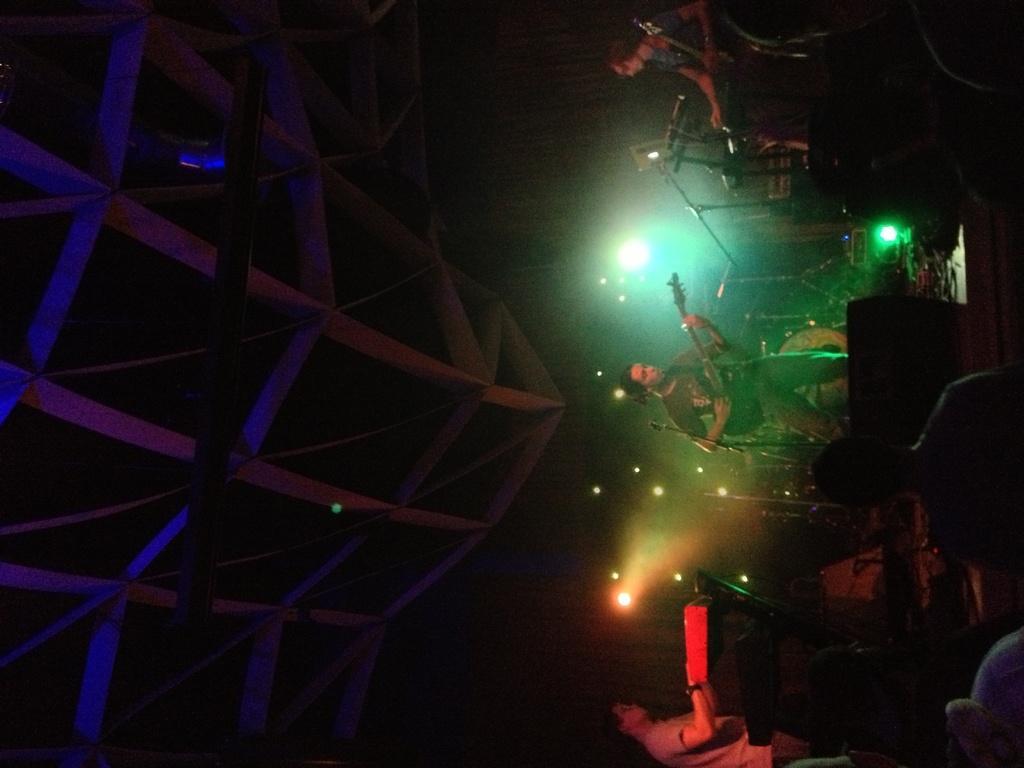In one or two sentences, can you explain what this image depicts? This is the picture of a place where we have some people playing some musical instruments and also we can see some lights and some other things around. 